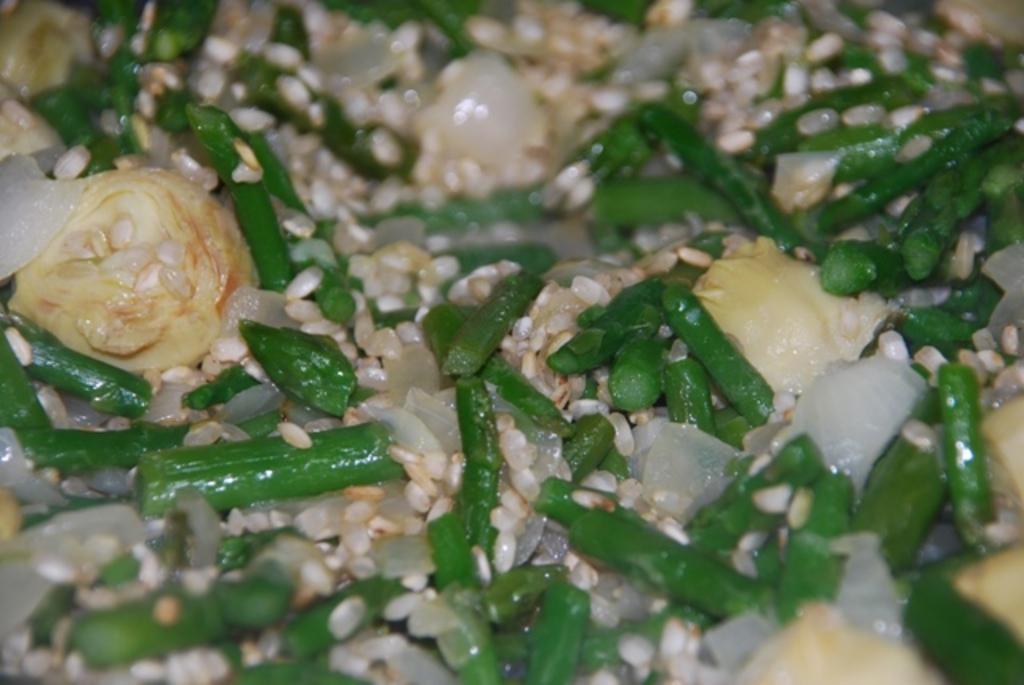In one or two sentences, can you explain what this image depicts? In this picture I can observe food in the middle of the picture. The food is in cream and green color. 